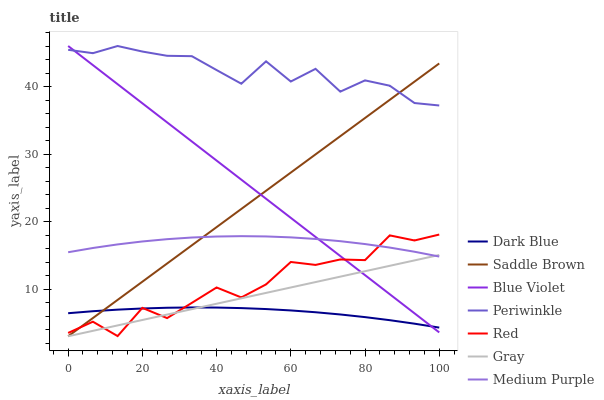Does Dark Blue have the minimum area under the curve?
Answer yes or no. Yes. Does Periwinkle have the maximum area under the curve?
Answer yes or no. Yes. Does Medium Purple have the minimum area under the curve?
Answer yes or no. No. Does Medium Purple have the maximum area under the curve?
Answer yes or no. No. Is Gray the smoothest?
Answer yes or no. Yes. Is Red the roughest?
Answer yes or no. Yes. Is Medium Purple the smoothest?
Answer yes or no. No. Is Medium Purple the roughest?
Answer yes or no. No. Does Gray have the lowest value?
Answer yes or no. Yes. Does Medium Purple have the lowest value?
Answer yes or no. No. Does Blue Violet have the highest value?
Answer yes or no. Yes. Does Medium Purple have the highest value?
Answer yes or no. No. Is Dark Blue less than Periwinkle?
Answer yes or no. Yes. Is Periwinkle greater than Gray?
Answer yes or no. Yes. Does Blue Violet intersect Saddle Brown?
Answer yes or no. Yes. Is Blue Violet less than Saddle Brown?
Answer yes or no. No. Is Blue Violet greater than Saddle Brown?
Answer yes or no. No. Does Dark Blue intersect Periwinkle?
Answer yes or no. No. 